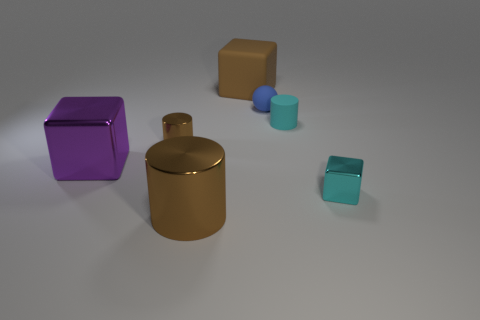There is a big rubber object; is its shape the same as the large shiny object that is behind the big brown shiny object?
Ensure brevity in your answer.  Yes. How many things are either tiny rubber objects that are on the right side of the small blue matte sphere or purple shiny blocks?
Your answer should be very brief. 2. Is there anything else that has the same material as the large brown cylinder?
Your answer should be very brief. Yes. What number of tiny things are on the right side of the brown matte block and in front of the tiny matte cylinder?
Provide a short and direct response. 1. What number of objects are tiny cyan objects behind the big metallic block or small cyan objects that are in front of the small cyan rubber cylinder?
Make the answer very short. 2. How many other things are there of the same shape as the tiny blue rubber thing?
Make the answer very short. 0. There is a big shiny thing that is on the left side of the large brown metal thing; does it have the same color as the big metallic cylinder?
Make the answer very short. No. What number of other objects are there of the same size as the matte block?
Your answer should be compact. 2. Do the small ball and the tiny cyan cylinder have the same material?
Your answer should be compact. Yes. What is the color of the tiny cylinder right of the object that is behind the blue matte sphere?
Provide a short and direct response. Cyan. 